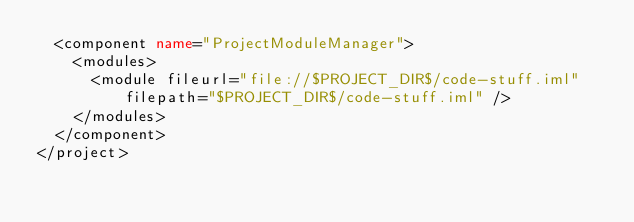Convert code to text. <code><loc_0><loc_0><loc_500><loc_500><_XML_>  <component name="ProjectModuleManager">
    <modules>
      <module fileurl="file://$PROJECT_DIR$/code-stuff.iml" filepath="$PROJECT_DIR$/code-stuff.iml" />
    </modules>
  </component>
</project></code> 